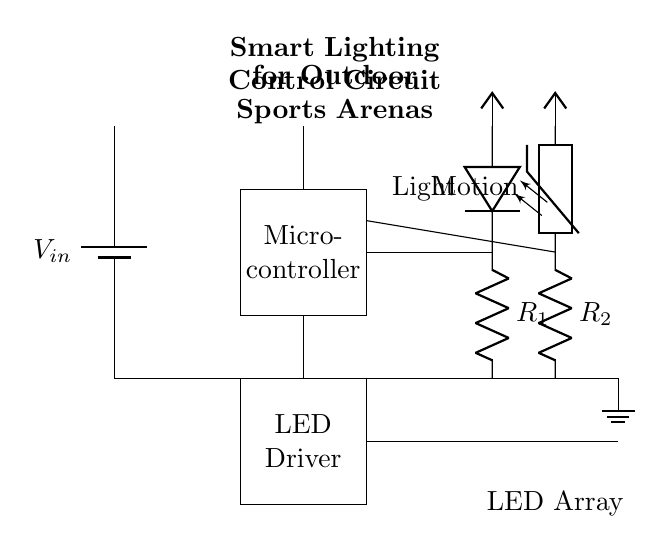What is the input voltage for this circuit? The input voltage, denoted by V_in in the circuit diagram, represents the power supply voltage provided to the circuit. It is connected to the battery symbol at the left side of the diagram.
Answer: V_in What components control the light in this circuit? The components involved in controlling the light are the light sensor (photodiode) and the motion sensor (thermistor), which influence the LED driver's operation based on environmental conditions.
Answer: Light sensor, motion sensor How many LEDs are there in the LED array? The LED array consists of three individual LEDs represented in the circuit diagram, each connected in series. Their arrangement indicates that they work together to provide illumination.
Answer: Three What is the function of the microcontroller in this circuit? The microcontroller acts as the control unit that processes signals from the light and motion sensors, determining the appropriate output to the LED driver based on the collected data.
Answer: Control unit Why is resistance used with the light sensor? Resistance (R1) is used with the light sensor to form a voltage divider circuit, allowing the sensor's output to be processed at appropriate levels by the microcontroller, thus ensuring accurate readings of light intensity.
Answer: To form a voltage divider How does the circuit adapt illumination for outdoor sports arenas? The circuit adapts illumination by utilizing sensors to detect changes in ambient light and motion, allowing the microcontroller to adjust the brightness of the LED array accordingly based on real-time conditions.
Answer: By using sensors for adaptation 